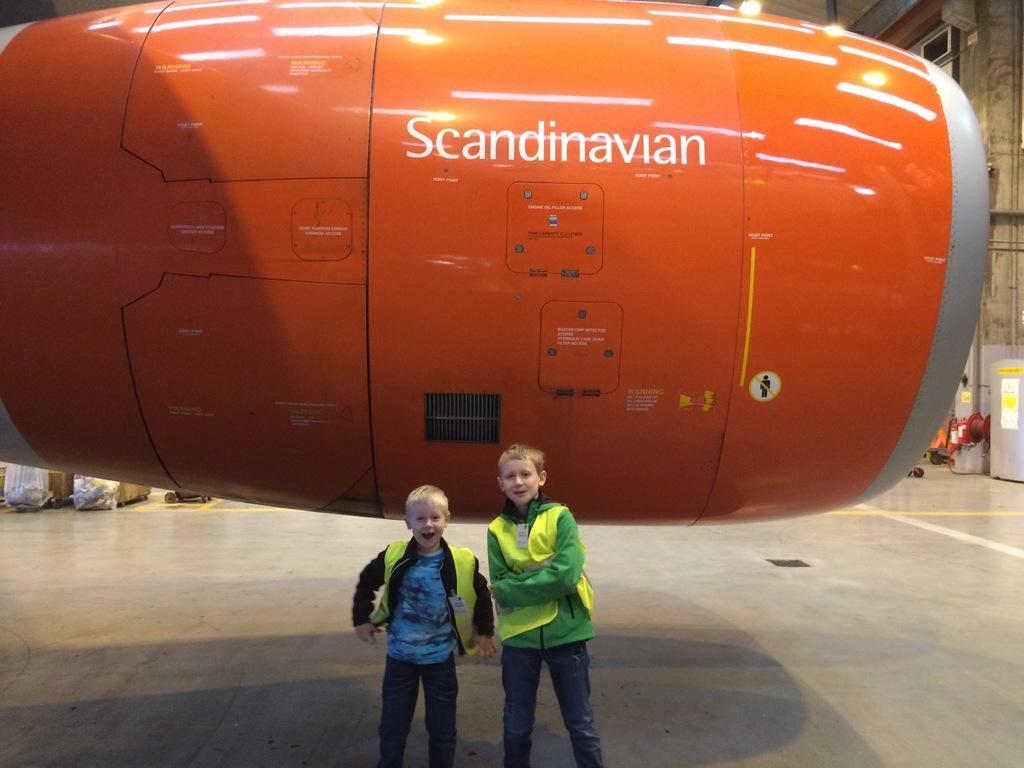Describe this image in one or two sentences. In this image I can see two boys are standing. I can see both of them are wearing jackets and I can see smile on their faces. In the background I can see an orange color object and on it I can see something is written. 